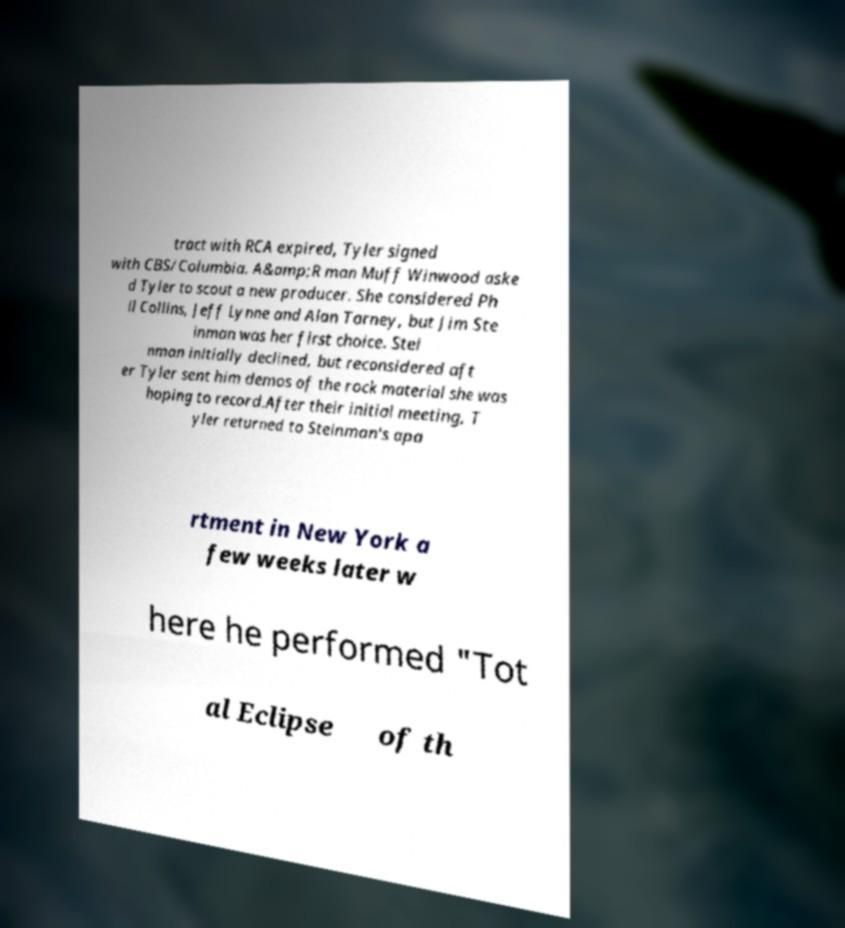For documentation purposes, I need the text within this image transcribed. Could you provide that? tract with RCA expired, Tyler signed with CBS/Columbia. A&amp;R man Muff Winwood aske d Tyler to scout a new producer. She considered Ph il Collins, Jeff Lynne and Alan Tarney, but Jim Ste inman was her first choice. Stei nman initially declined, but reconsidered aft er Tyler sent him demos of the rock material she was hoping to record.After their initial meeting, T yler returned to Steinman's apa rtment in New York a few weeks later w here he performed "Tot al Eclipse of th 